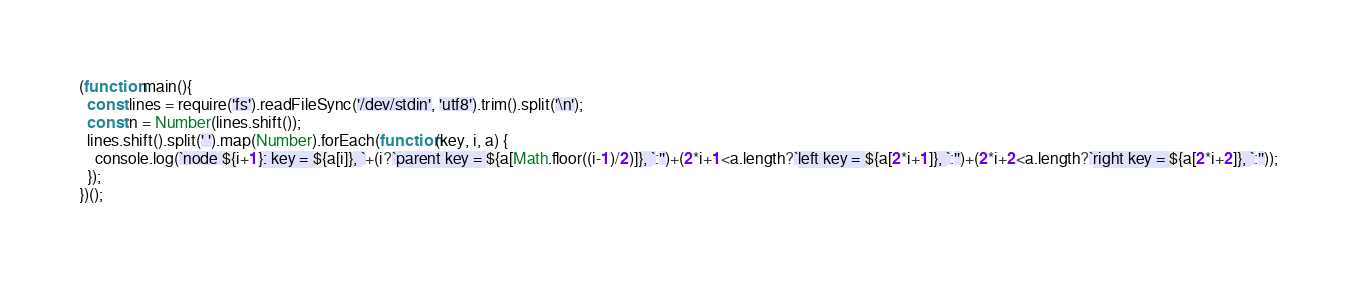Convert code to text. <code><loc_0><loc_0><loc_500><loc_500><_JavaScript_>(function main(){
  const lines = require('fs').readFileSync('/dev/stdin', 'utf8').trim().split('\n');
  const n = Number(lines.shift());
  lines.shift().split(' ').map(Number).forEach(function(key, i, a) {
    console.log(`node ${i+1}: key = ${a[i]}, `+(i?`parent key = ${a[Math.floor((i-1)/2)]}, `:'')+(2*i+1<a.length?`left key = ${a[2*i+1]}, `:'')+(2*i+2<a.length?`right key = ${a[2*i+2]}, `:''));
  });
})();

</code> 